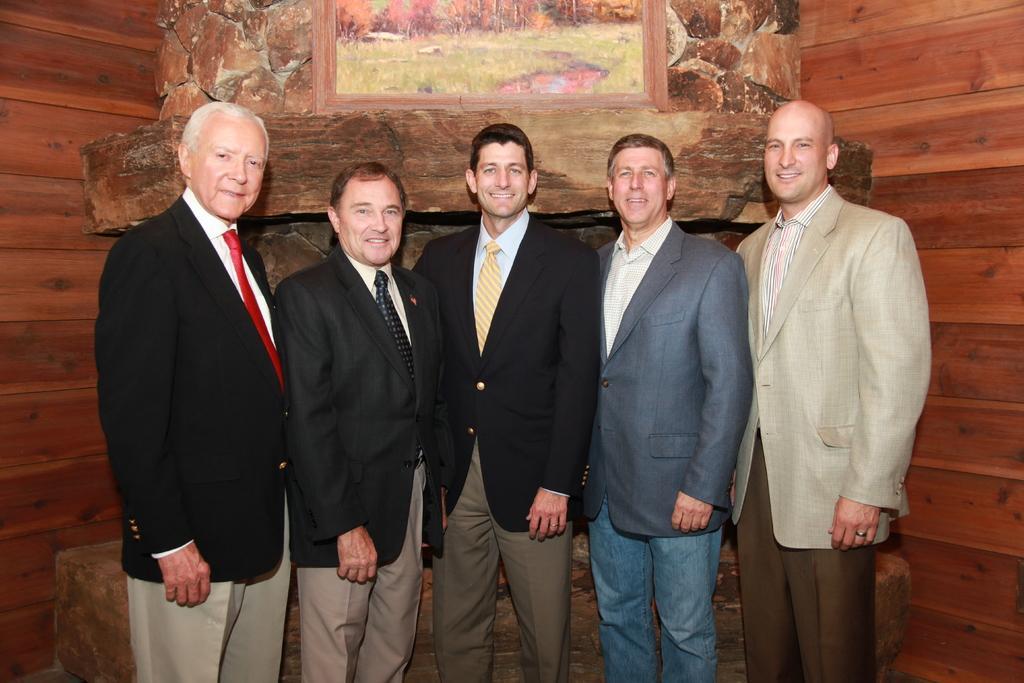Could you give a brief overview of what you see in this image? In this image I can see few people are standing and they are wearing different color dresses. Back I can see a frame and brown background. 